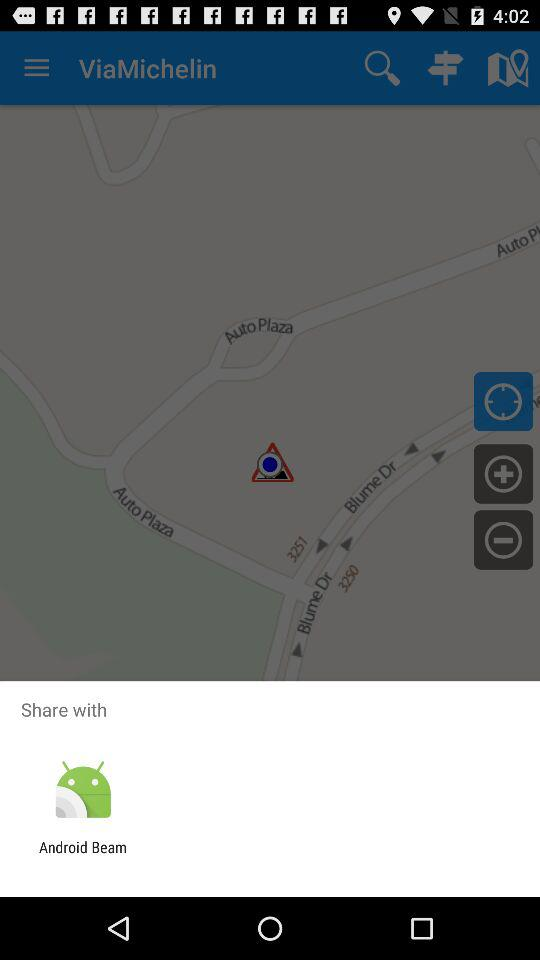What option is given for sharing? The given option is "Android Beam". 